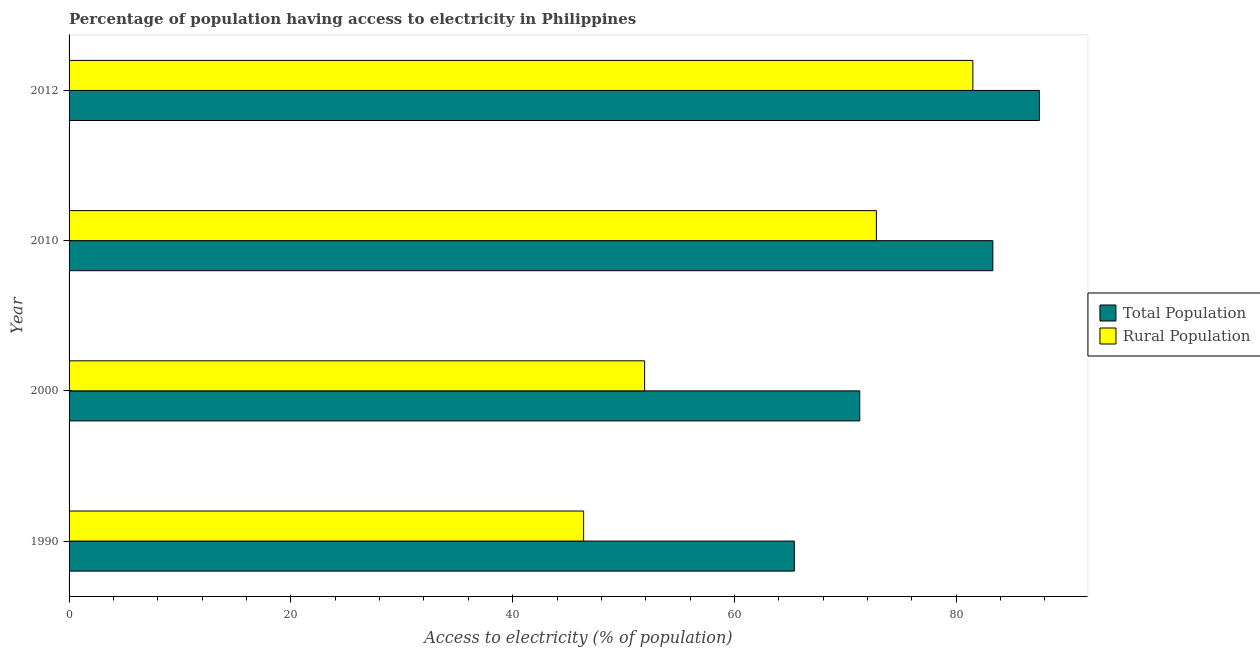How many different coloured bars are there?
Your answer should be very brief. 2. Are the number of bars on each tick of the Y-axis equal?
Offer a very short reply. Yes. How many bars are there on the 2nd tick from the bottom?
Make the answer very short. 2. What is the label of the 4th group of bars from the top?
Provide a short and direct response. 1990. In how many cases, is the number of bars for a given year not equal to the number of legend labels?
Provide a short and direct response. 0. What is the percentage of rural population having access to electricity in 2000?
Your answer should be compact. 51.9. Across all years, what is the maximum percentage of rural population having access to electricity?
Give a very brief answer. 81.5. Across all years, what is the minimum percentage of population having access to electricity?
Give a very brief answer. 65.4. In which year was the percentage of population having access to electricity minimum?
Your answer should be very brief. 1990. What is the total percentage of population having access to electricity in the graph?
Your answer should be very brief. 307.5. What is the difference between the percentage of rural population having access to electricity in 2012 and the percentage of population having access to electricity in 1990?
Make the answer very short. 16.1. What is the average percentage of rural population having access to electricity per year?
Your answer should be very brief. 63.15. What is the ratio of the percentage of rural population having access to electricity in 1990 to that in 2012?
Your answer should be compact. 0.57. Is the percentage of population having access to electricity in 2010 less than that in 2012?
Give a very brief answer. Yes. What is the difference between the highest and the second highest percentage of population having access to electricity?
Your response must be concise. 4.2. What is the difference between the highest and the lowest percentage of population having access to electricity?
Provide a short and direct response. 22.1. In how many years, is the percentage of population having access to electricity greater than the average percentage of population having access to electricity taken over all years?
Your answer should be compact. 2. Is the sum of the percentage of rural population having access to electricity in 2010 and 2012 greater than the maximum percentage of population having access to electricity across all years?
Your answer should be very brief. Yes. What does the 1st bar from the top in 2012 represents?
Give a very brief answer. Rural Population. What does the 2nd bar from the bottom in 2010 represents?
Offer a very short reply. Rural Population. How many bars are there?
Keep it short and to the point. 8. Are the values on the major ticks of X-axis written in scientific E-notation?
Keep it short and to the point. No. How many legend labels are there?
Ensure brevity in your answer.  2. How are the legend labels stacked?
Keep it short and to the point. Vertical. What is the title of the graph?
Make the answer very short. Percentage of population having access to electricity in Philippines. Does "RDB nonconcessional" appear as one of the legend labels in the graph?
Offer a terse response. No. What is the label or title of the X-axis?
Your answer should be very brief. Access to electricity (% of population). What is the label or title of the Y-axis?
Offer a very short reply. Year. What is the Access to electricity (% of population) in Total Population in 1990?
Keep it short and to the point. 65.4. What is the Access to electricity (% of population) of Rural Population in 1990?
Offer a very short reply. 46.4. What is the Access to electricity (% of population) of Total Population in 2000?
Offer a very short reply. 71.3. What is the Access to electricity (% of population) of Rural Population in 2000?
Provide a short and direct response. 51.9. What is the Access to electricity (% of population) in Total Population in 2010?
Ensure brevity in your answer.  83.3. What is the Access to electricity (% of population) of Rural Population in 2010?
Offer a very short reply. 72.8. What is the Access to electricity (% of population) in Total Population in 2012?
Make the answer very short. 87.5. What is the Access to electricity (% of population) of Rural Population in 2012?
Provide a succinct answer. 81.5. Across all years, what is the maximum Access to electricity (% of population) of Total Population?
Provide a succinct answer. 87.5. Across all years, what is the maximum Access to electricity (% of population) of Rural Population?
Offer a very short reply. 81.5. Across all years, what is the minimum Access to electricity (% of population) of Total Population?
Offer a terse response. 65.4. Across all years, what is the minimum Access to electricity (% of population) in Rural Population?
Your answer should be compact. 46.4. What is the total Access to electricity (% of population) in Total Population in the graph?
Keep it short and to the point. 307.5. What is the total Access to electricity (% of population) of Rural Population in the graph?
Offer a very short reply. 252.6. What is the difference between the Access to electricity (% of population) in Total Population in 1990 and that in 2010?
Give a very brief answer. -17.9. What is the difference between the Access to electricity (% of population) in Rural Population in 1990 and that in 2010?
Your answer should be compact. -26.4. What is the difference between the Access to electricity (% of population) of Total Population in 1990 and that in 2012?
Offer a terse response. -22.1. What is the difference between the Access to electricity (% of population) in Rural Population in 1990 and that in 2012?
Give a very brief answer. -35.1. What is the difference between the Access to electricity (% of population) of Total Population in 2000 and that in 2010?
Ensure brevity in your answer.  -12. What is the difference between the Access to electricity (% of population) in Rural Population in 2000 and that in 2010?
Make the answer very short. -20.9. What is the difference between the Access to electricity (% of population) in Total Population in 2000 and that in 2012?
Your answer should be compact. -16.2. What is the difference between the Access to electricity (% of population) of Rural Population in 2000 and that in 2012?
Keep it short and to the point. -29.6. What is the difference between the Access to electricity (% of population) of Total Population in 2010 and that in 2012?
Your response must be concise. -4.2. What is the difference between the Access to electricity (% of population) of Rural Population in 2010 and that in 2012?
Give a very brief answer. -8.7. What is the difference between the Access to electricity (% of population) of Total Population in 1990 and the Access to electricity (% of population) of Rural Population in 2000?
Offer a terse response. 13.5. What is the difference between the Access to electricity (% of population) of Total Population in 1990 and the Access to electricity (% of population) of Rural Population in 2012?
Provide a short and direct response. -16.1. What is the difference between the Access to electricity (% of population) in Total Population in 2000 and the Access to electricity (% of population) in Rural Population in 2012?
Offer a very short reply. -10.2. What is the average Access to electricity (% of population) in Total Population per year?
Offer a very short reply. 76.88. What is the average Access to electricity (% of population) in Rural Population per year?
Make the answer very short. 63.15. In the year 2000, what is the difference between the Access to electricity (% of population) in Total Population and Access to electricity (% of population) in Rural Population?
Provide a succinct answer. 19.4. In the year 2010, what is the difference between the Access to electricity (% of population) in Total Population and Access to electricity (% of population) in Rural Population?
Ensure brevity in your answer.  10.5. What is the ratio of the Access to electricity (% of population) of Total Population in 1990 to that in 2000?
Make the answer very short. 0.92. What is the ratio of the Access to electricity (% of population) in Rural Population in 1990 to that in 2000?
Make the answer very short. 0.89. What is the ratio of the Access to electricity (% of population) in Total Population in 1990 to that in 2010?
Offer a very short reply. 0.79. What is the ratio of the Access to electricity (% of population) in Rural Population in 1990 to that in 2010?
Ensure brevity in your answer.  0.64. What is the ratio of the Access to electricity (% of population) in Total Population in 1990 to that in 2012?
Your answer should be very brief. 0.75. What is the ratio of the Access to electricity (% of population) of Rural Population in 1990 to that in 2012?
Your answer should be compact. 0.57. What is the ratio of the Access to electricity (% of population) of Total Population in 2000 to that in 2010?
Your response must be concise. 0.86. What is the ratio of the Access to electricity (% of population) of Rural Population in 2000 to that in 2010?
Your answer should be very brief. 0.71. What is the ratio of the Access to electricity (% of population) in Total Population in 2000 to that in 2012?
Give a very brief answer. 0.81. What is the ratio of the Access to electricity (% of population) in Rural Population in 2000 to that in 2012?
Your response must be concise. 0.64. What is the ratio of the Access to electricity (% of population) in Total Population in 2010 to that in 2012?
Make the answer very short. 0.95. What is the ratio of the Access to electricity (% of population) of Rural Population in 2010 to that in 2012?
Provide a short and direct response. 0.89. What is the difference between the highest and the second highest Access to electricity (% of population) of Total Population?
Make the answer very short. 4.2. What is the difference between the highest and the second highest Access to electricity (% of population) in Rural Population?
Your response must be concise. 8.7. What is the difference between the highest and the lowest Access to electricity (% of population) of Total Population?
Offer a very short reply. 22.1. What is the difference between the highest and the lowest Access to electricity (% of population) of Rural Population?
Provide a succinct answer. 35.1. 